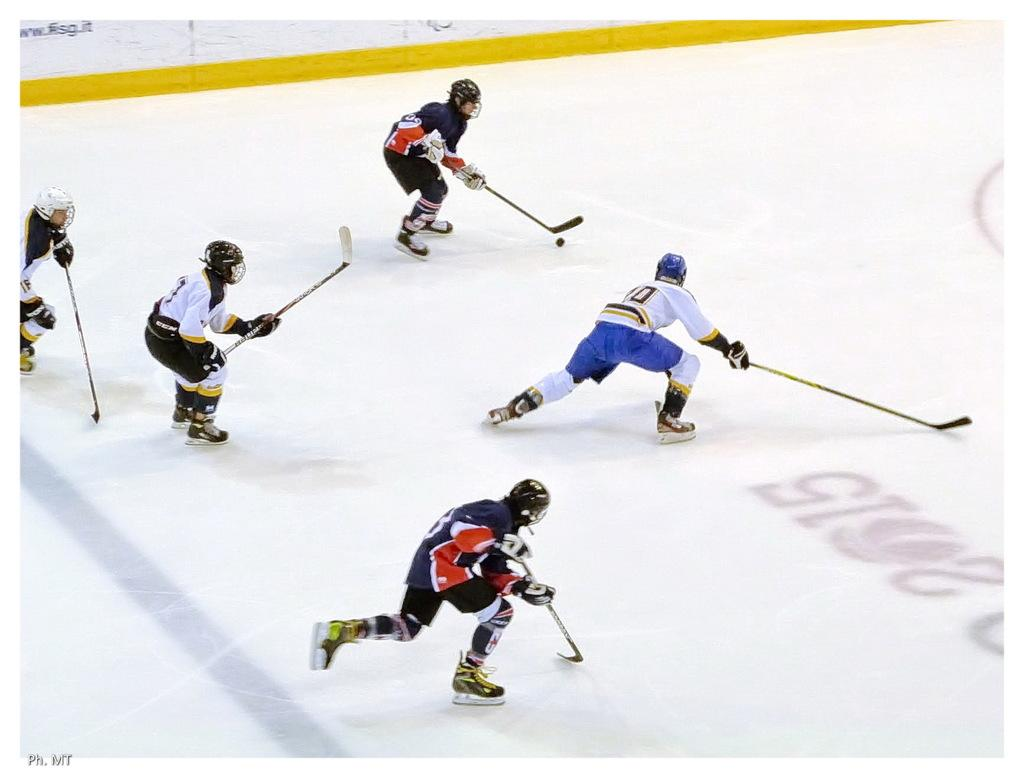What sport are the players engaged in within the image? The players are playing ice hockey. What protective gear are the players wearing on their heads? The players are wearing helmets on their heads. What type of rose can be seen growing on the ice during the ice hockey game? There is no rose present in the image; it features players engaged in an ice hockey game. 